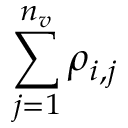<formula> <loc_0><loc_0><loc_500><loc_500>\sum _ { j = 1 } ^ { n _ { v } } \rho _ { i , j }</formula> 